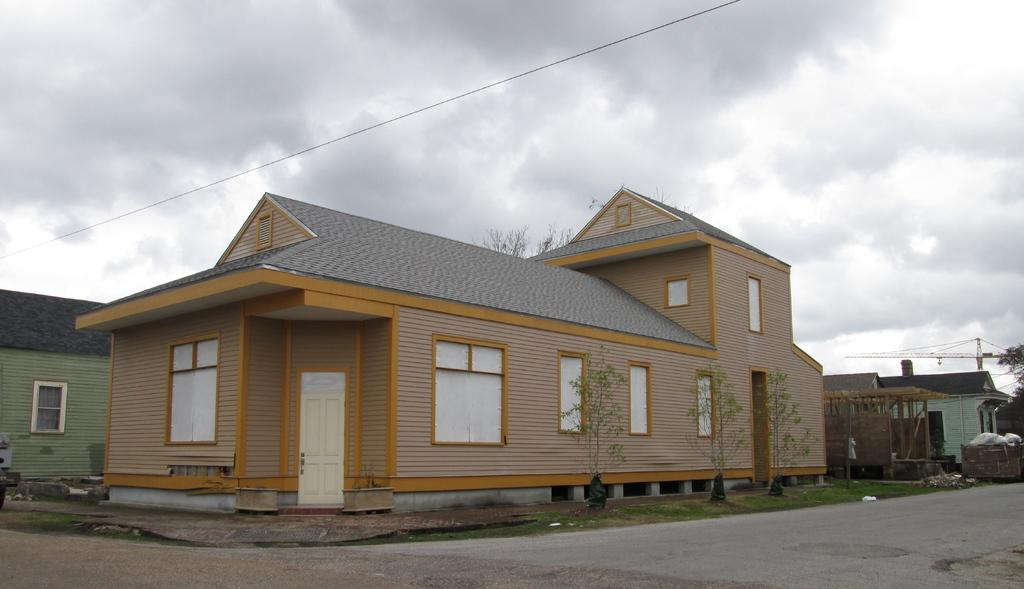What type of surface can be seen in the image? There is a road in the image. What type of structures are visible in the image? There are houses in the image. What type of vegetation is present in the image? There are plants, trees, and grass in the image. What object might be used for waste disposal in the image? There is a garbage bin with trash in the image. What type of construction equipment can be seen in the image? There is a crane in the image. What type of utility infrastructure is present in the image? There are wires in the image. What can be seen in the background of the image? The sky is visible in the background of the image. What type of mouth can be seen on the crane in the image? There is no mouth present on the crane in the image; it is a piece of construction equipment. What type of tail can be seen on the garbage bin in the image? There is no tail present on the garbage bin in the image; it is a waste disposal container. 